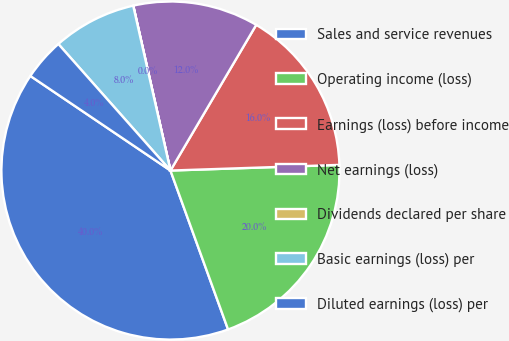<chart> <loc_0><loc_0><loc_500><loc_500><pie_chart><fcel>Sales and service revenues<fcel>Operating income (loss)<fcel>Earnings (loss) before income<fcel>Net earnings (loss)<fcel>Dividends declared per share<fcel>Basic earnings (loss) per<fcel>Diluted earnings (loss) per<nl><fcel>39.99%<fcel>20.0%<fcel>16.0%<fcel>12.0%<fcel>0.01%<fcel>8.0%<fcel>4.01%<nl></chart> 